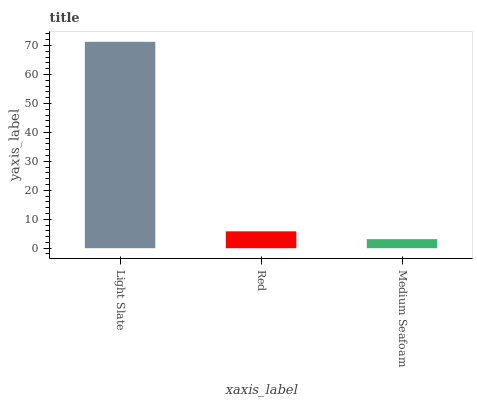Is Red the minimum?
Answer yes or no. No. Is Red the maximum?
Answer yes or no. No. Is Light Slate greater than Red?
Answer yes or no. Yes. Is Red less than Light Slate?
Answer yes or no. Yes. Is Red greater than Light Slate?
Answer yes or no. No. Is Light Slate less than Red?
Answer yes or no. No. Is Red the high median?
Answer yes or no. Yes. Is Red the low median?
Answer yes or no. Yes. Is Medium Seafoam the high median?
Answer yes or no. No. Is Light Slate the low median?
Answer yes or no. No. 